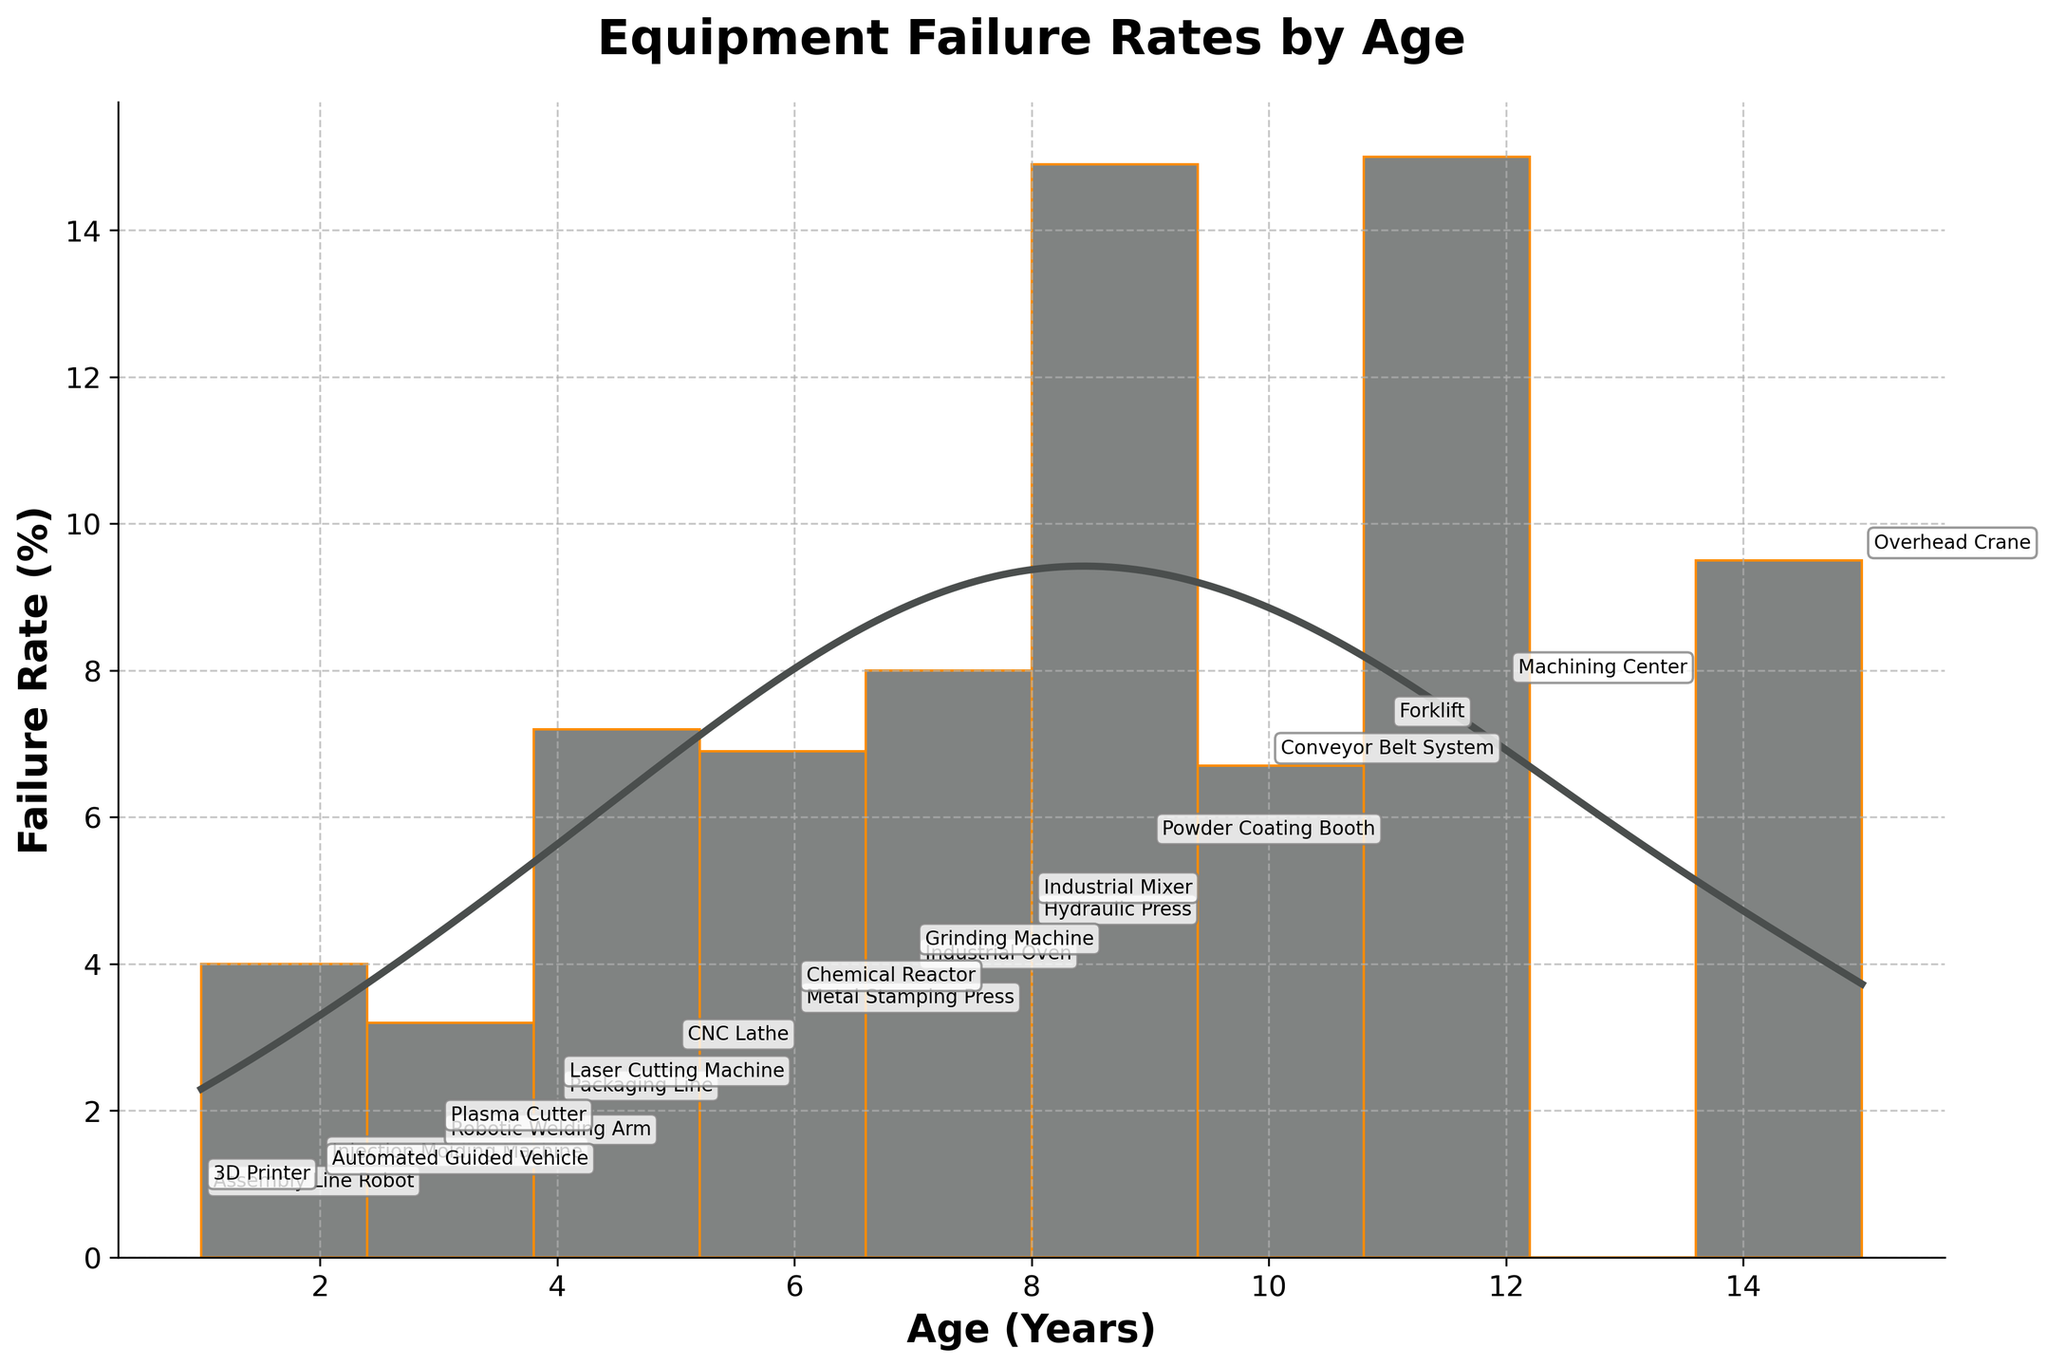What is the title of the plot? The title of the plot is located at the top and is a summary of what the plot represents. It usually provides an overview. In this case, the title "Equipment Failure Rates by Age" tells us the plot is about how equipment failure rates change with age.
Answer: Equipment Failure Rates by Age What are the labels on the X and Y axes? The labels on the X and Y axes give us information about what each axis represents. The X-axis label "Age (Years)" indicates that the age of equipment in years is plotted along the horizontal axis. The Y-axis label "Failure Rate (%)" indicates that the failure rates in percentage are plotted along the vertical axis.
Answer: Age (Years), Failure Rate (%) How many equipment types are included in the plot? Count the labels or annotations on the plot, each representing a different type of equipment. Since each piece of equipment is labeled, we can count the total number of these labels.
Answer: 20 Which equipment type has the highest failure rate? Check the plot for the data point with the highest value on the Y-axis and identify the corresponding label for that data point. The highest failure rate is near the upper end of the Y-axis at 9.5%. The label there is "Overhead Crane."
Answer: Overhead Crane What is the age and failure rate percentage of the oldest equipment? Identify the data point which is the farthest right on the X-axis, indicating the maximum age. Then check the failure rate of this data point. The oldest equipment has an age of 15 years and a failure rate of 9.5%.
Answer: 15 years, 9.5% Which equipment has a failure rate between 4% and 5%? Look at the Y-axis values between 4% and 5% and find the corresponding labels. The labels connected to this range are "Hydraulic Press" (4.5%), "Grinding Machine" (4.1%), and "Industrial Mixer" (4.8%).
Answer: Hydraulic Press, Grinding Machine, Industrial Mixer Are there more equipments with ages below 5 years or above 10 years? Count the number of data points below 5 years and those above 10 years. For below 5 years: 5 data points ("Injection Molding Machine", "Robotic Welding Arm", "Assembly Line Robot", "3D Printer", "Automated Guided Vehicle"). For above 10 years: 3 data points ("Machining Center", "Forklift", "Overhead Crane").
Answer: Below 5 years What is the approximate age range in which failure rates are highest according to the density curve? Analyze the KDE (density curve) to determine where it shows the highest peak, which indicates the age range where failure rates are most concentrated. The peak in the density curve appears around the 6 to 10 year mark.
Answer: 6 to 10 years Which age group has the lowest failure rate? Identify the part of the plot where the lowest value on the Y-axis intersects with an age group on the X-axis. The lowest failure rate is seen at age 1 year with Equipment "Assembly Line Robot" and "3D Printer", both having approximately 0.8% and 0.9% respectively.
Answer: 1 year 